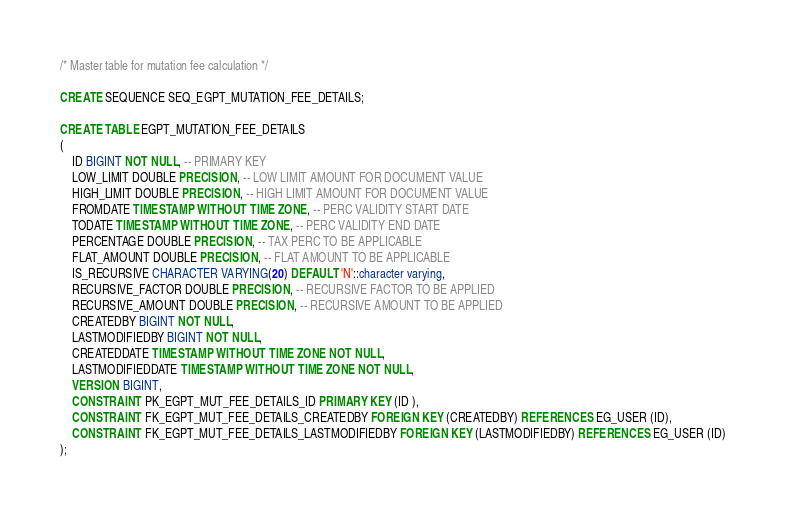Convert code to text. <code><loc_0><loc_0><loc_500><loc_500><_SQL_>/* Master table for mutation fee calculation */

CREATE SEQUENCE SEQ_EGPT_MUTATION_FEE_DETAILS;

CREATE TABLE EGPT_MUTATION_FEE_DETAILS
(
	ID BIGINT NOT NULL, -- PRIMARY KEY
	LOW_LIMIT DOUBLE PRECISION, -- LOW LIMIT AMOUNT FOR DOCUMENT VALUE
	HIGH_LIMIT DOUBLE PRECISION, -- HIGH LIMIT AMOUNT FOR DOCUMENT VALUE
	FROMDATE TIMESTAMP WITHOUT TIME ZONE, -- PERC VALIDITY START DATE
	TODATE TIMESTAMP WITHOUT TIME ZONE, -- PERC VALIDITY END DATE
	PERCENTAGE DOUBLE PRECISION, -- TAX PERC TO BE APPLICABLE
	FLAT_AMOUNT DOUBLE PRECISION, -- FLAT AMOUNT TO BE APPLICABLE
	IS_RECURSIVE CHARACTER VARYING(20) DEFAULT 'N'::character varying,
	RECURSIVE_FACTOR DOUBLE PRECISION, -- RECURSIVE FACTOR TO BE APPLIED
	RECURSIVE_AMOUNT DOUBLE PRECISION, -- RECURSIVE AMOUNT TO BE APPLIED
	CREATEDBY BIGINT NOT NULL,
	LASTMODIFIEDBY BIGINT NOT NULL,
	CREATEDDATE TIMESTAMP WITHOUT TIME ZONE NOT NULL,
	LASTMODIFIEDDATE TIMESTAMP WITHOUT TIME ZONE NOT NULL,
	VERSION BIGINT,
	CONSTRAINT PK_EGPT_MUT_FEE_DETAILS_ID PRIMARY KEY (ID ),
	CONSTRAINT FK_EGPT_MUT_FEE_DETAILS_CREATEDBY FOREIGN KEY (CREATEDBY) REFERENCES EG_USER (ID),
	CONSTRAINT FK_EGPT_MUT_FEE_DETAILS_LASTMODIFIEDBY FOREIGN KEY (LASTMODIFIEDBY) REFERENCES EG_USER (ID)
);


</code> 